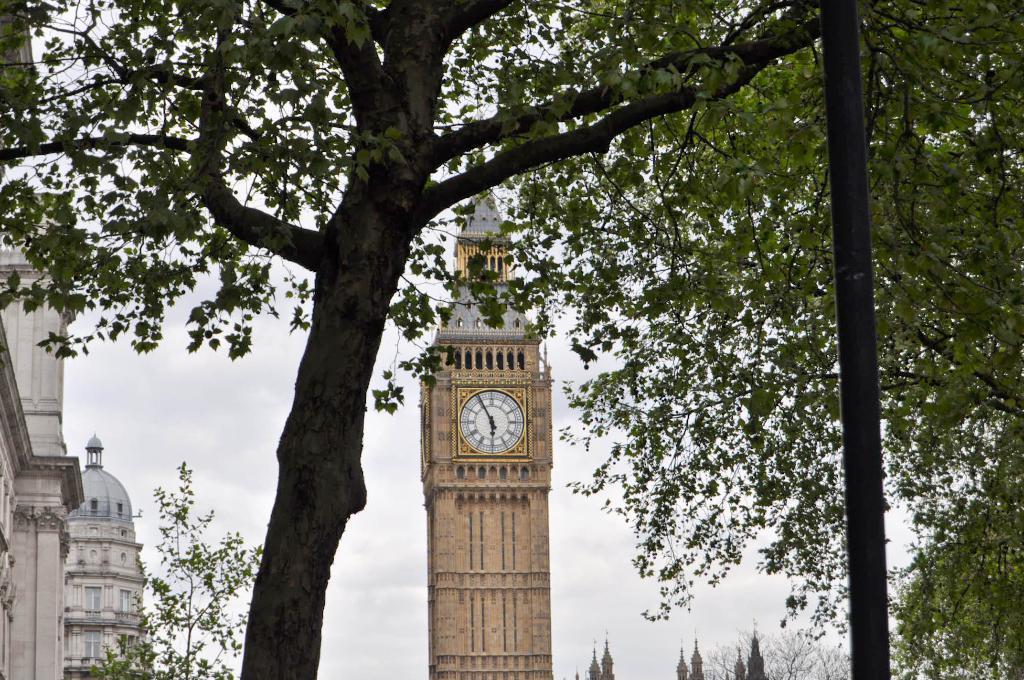How would you summarize this image in a sentence or two? In this picture there is a tree towards the left. On the background there is a tower with a clock. Towards the left there are buildings and trees. 